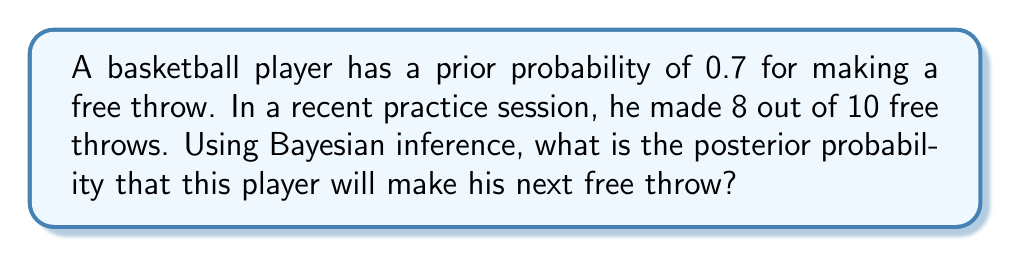What is the answer to this math problem? Let's approach this step-by-step using Bayesian inference:

1) Let $\theta$ be the probability of making a free throw.

2) Prior probability: $P(\theta) = 0.7$

3) Likelihood: We observed 8 successes out of 10 trials. This follows a Binomial distribution.
   $P(X=8|\theta) = \binom{10}{8} \theta^8 (1-\theta)^2$

4) Bayes' theorem states:
   $$P(\theta|X) = \frac{P(X|\theta)P(\theta)}{P(X)}$$

5) The denominator $P(X)$ is a normalizing constant. We can ignore it for now and use proportionality:
   $$P(\theta|X) \propto P(X|\theta)P(\theta)$$

6) Substituting our values:
   $$P(\theta|X=8) \propto \binom{10}{8} \theta^8 (1-\theta)^2 \cdot 0.7$$

7) The posterior distribution is a Beta distribution with parameters $\alpha = 9$ and $\beta = 3$:
   $$P(\theta|X=8) \sim \text{Beta}(9, 3)$$

8) The expected value of a Beta(α, β) distribution is $\frac{\alpha}{\alpha + \beta}$

9) Therefore, our posterior probability is:
   $$E[\theta|X=8] = \frac{9}{9 + 3} = \frac{9}{12} = 0.75$$
Answer: 0.75 